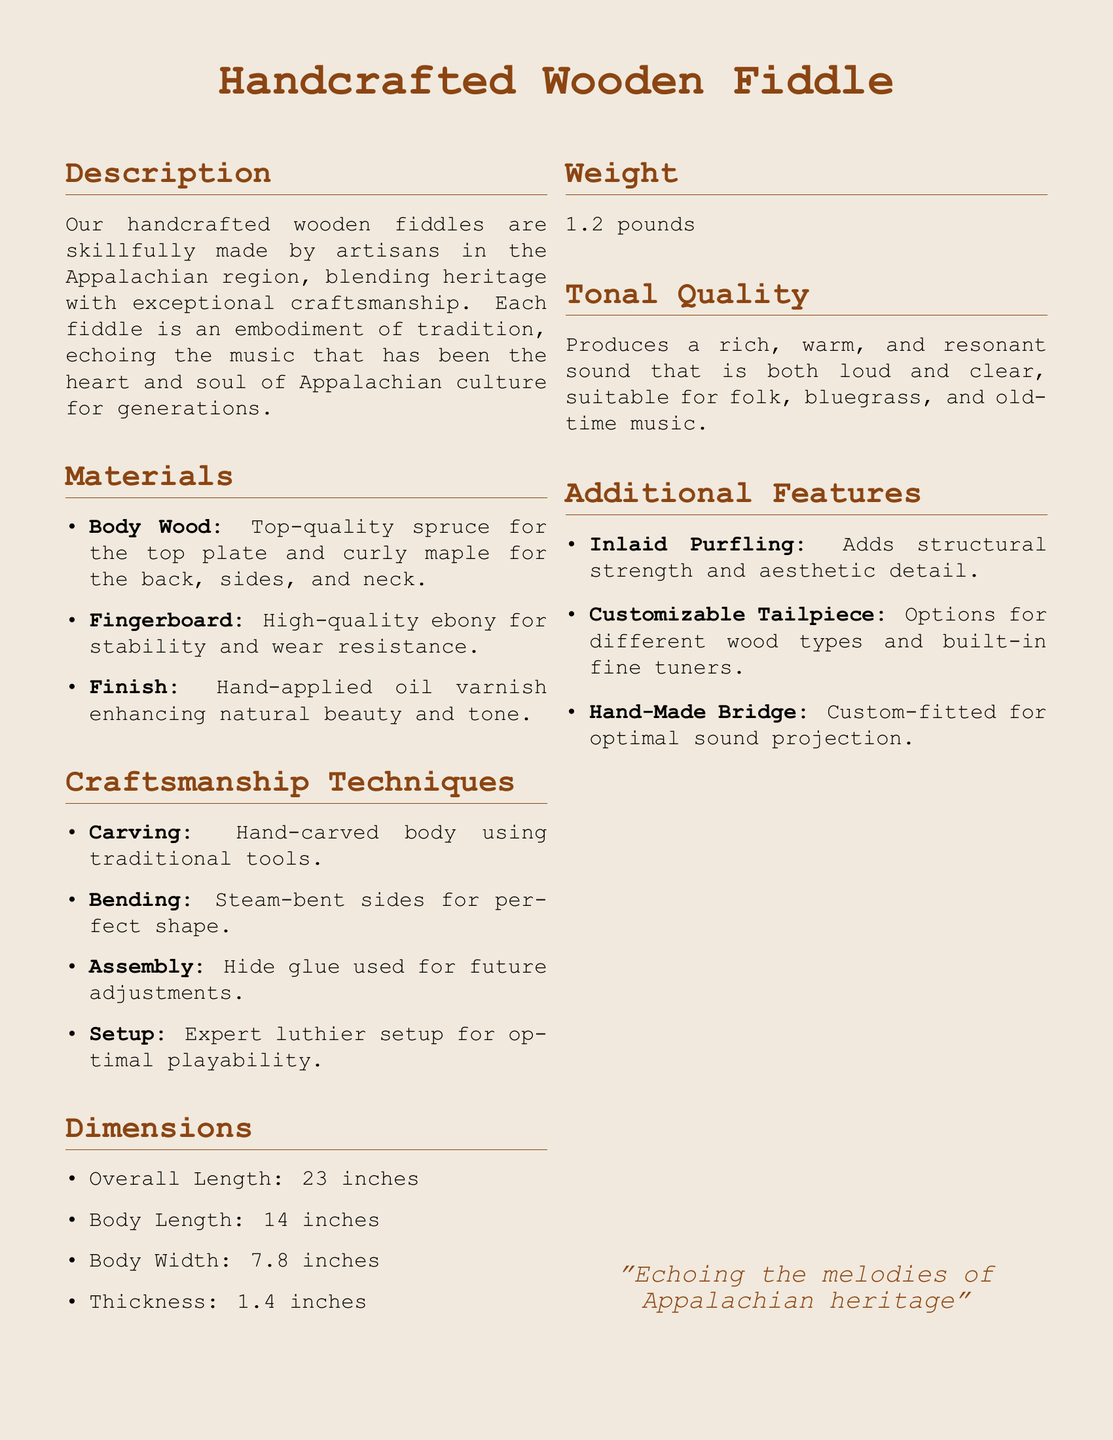what types of wood are used for the body? The body wood consists of top-quality spruce for the top plate and curly maple for the back, sides, and neck.
Answer: spruce and curly maple what is the weight of the fiddle? The weight section specifies the weight of the fiddle as a key detail.
Answer: 1.2 pounds how long is the overall length of the fiddle? Overall length is a specific measurement included in the dimensions section of the document.
Answer: 23 inches what varnish is used? The finish section mentions that a hand-applied oil varnish is used to enhance the fiddle's natural beauty.
Answer: hand-applied oil varnish what craftsmanship technique involves steam? The bending technique specified in the craftsmanship section utilizes steam for shaping the sides.
Answer: steam-bent why is hide glue used in assembly? Hide glue allows for future adjustments, indicating its significance in craftsmanship.
Answer: future adjustments what feature adds structural strength? The inlaid purfling mentioned in the additional features contributes to structural strength.
Answer: inlaid purfling what is the body width of the fiddle? The body width is stated in the dimensions section, providing an important measurement.
Answer: 7.8 inches which music styles is the fiddle suitable for? The tonal quality section highlights that the fiddle produces a sound suitable for specific genres.
Answer: folk, bluegrass, and old-time music 